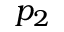Convert formula to latex. <formula><loc_0><loc_0><loc_500><loc_500>p _ { 2 }</formula> 